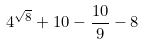Convert formula to latex. <formula><loc_0><loc_0><loc_500><loc_500>4 ^ { \sqrt { 8 } } + 1 0 - \frac { 1 0 } { 9 } - 8</formula> 